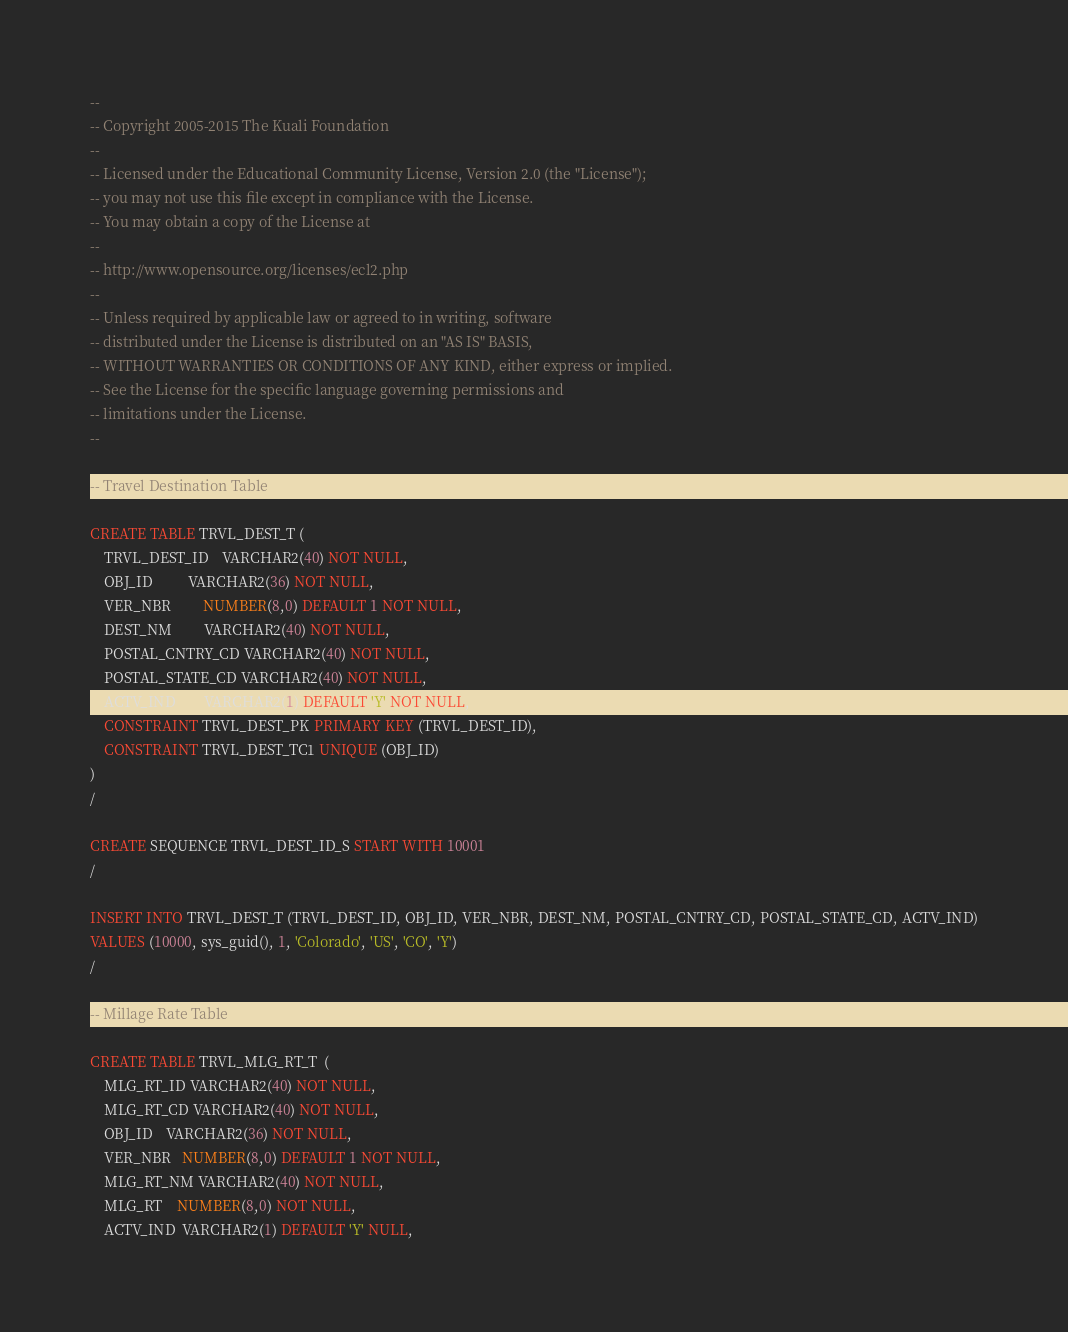<code> <loc_0><loc_0><loc_500><loc_500><_SQL_>--
-- Copyright 2005-2015 The Kuali Foundation
--
-- Licensed under the Educational Community License, Version 2.0 (the "License");
-- you may not use this file except in compliance with the License.
-- You may obtain a copy of the License at
--
-- http://www.opensource.org/licenses/ecl2.php
--
-- Unless required by applicable law or agreed to in writing, software
-- distributed under the License is distributed on an "AS IS" BASIS,
-- WITHOUT WARRANTIES OR CONDITIONS OF ANY KIND, either express or implied.
-- See the License for the specific language governing permissions and
-- limitations under the License.
--

-- Travel Destination Table

CREATE TABLE TRVL_DEST_T (
    TRVL_DEST_ID    VARCHAR2(40) NOT NULL,
    OBJ_ID          VARCHAR2(36) NOT NULL,
    VER_NBR         NUMBER(8,0) DEFAULT 1 NOT NULL,
    DEST_NM         VARCHAR2(40) NOT NULL,
    POSTAL_CNTRY_CD VARCHAR2(40) NOT NULL,
    POSTAL_STATE_CD VARCHAR2(40) NOT NULL,
    ACTV_IND        VARCHAR2(1) DEFAULT 'Y' NOT NULL,
    CONSTRAINT TRVL_DEST_PK PRIMARY KEY (TRVL_DEST_ID),
    CONSTRAINT TRVL_DEST_TC1 UNIQUE (OBJ_ID)
)
/

CREATE SEQUENCE TRVL_DEST_ID_S START WITH 10001
/

INSERT INTO TRVL_DEST_T (TRVL_DEST_ID, OBJ_ID, VER_NBR, DEST_NM, POSTAL_CNTRY_CD, POSTAL_STATE_CD, ACTV_IND)
VALUES (10000, sys_guid(), 1, 'Colorado', 'US', 'CO', 'Y')
/

-- Millage Rate Table

CREATE TABLE TRVL_MLG_RT_T  (
    MLG_RT_ID VARCHAR2(40) NOT NULL,
    MLG_RT_CD VARCHAR2(40) NOT NULL,
    OBJ_ID    VARCHAR2(36) NOT NULL,
    VER_NBR   NUMBER(8,0) DEFAULT 1 NOT NULL,
    MLG_RT_NM VARCHAR2(40) NOT NULL,
    MLG_RT    NUMBER(8,0) NOT NULL,
    ACTV_IND  VARCHAR2(1) DEFAULT 'Y' NULL,</code> 